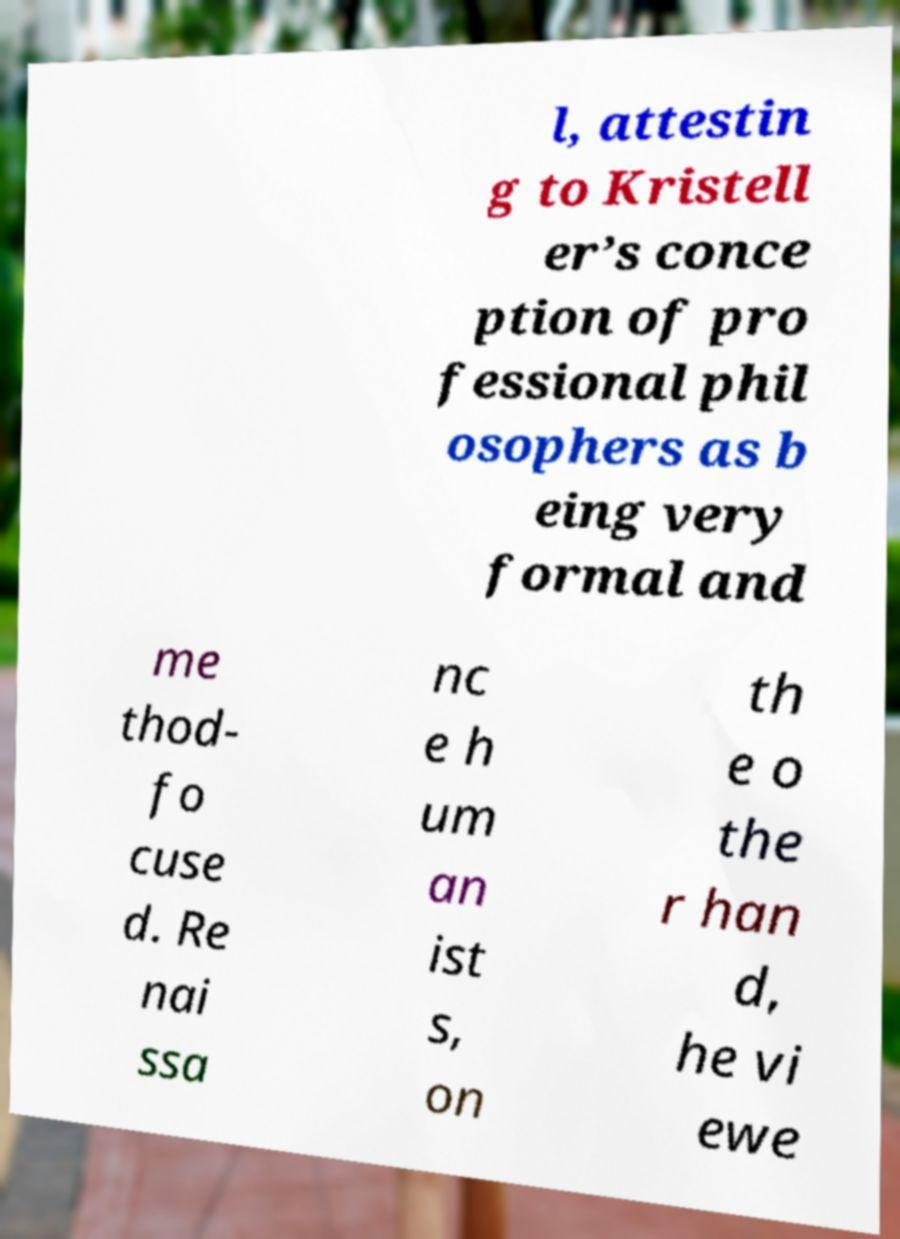There's text embedded in this image that I need extracted. Can you transcribe it verbatim? l, attestin g to Kristell er’s conce ption of pro fessional phil osophers as b eing very formal and me thod- fo cuse d. Re nai ssa nc e h um an ist s, on th e o the r han d, he vi ewe 